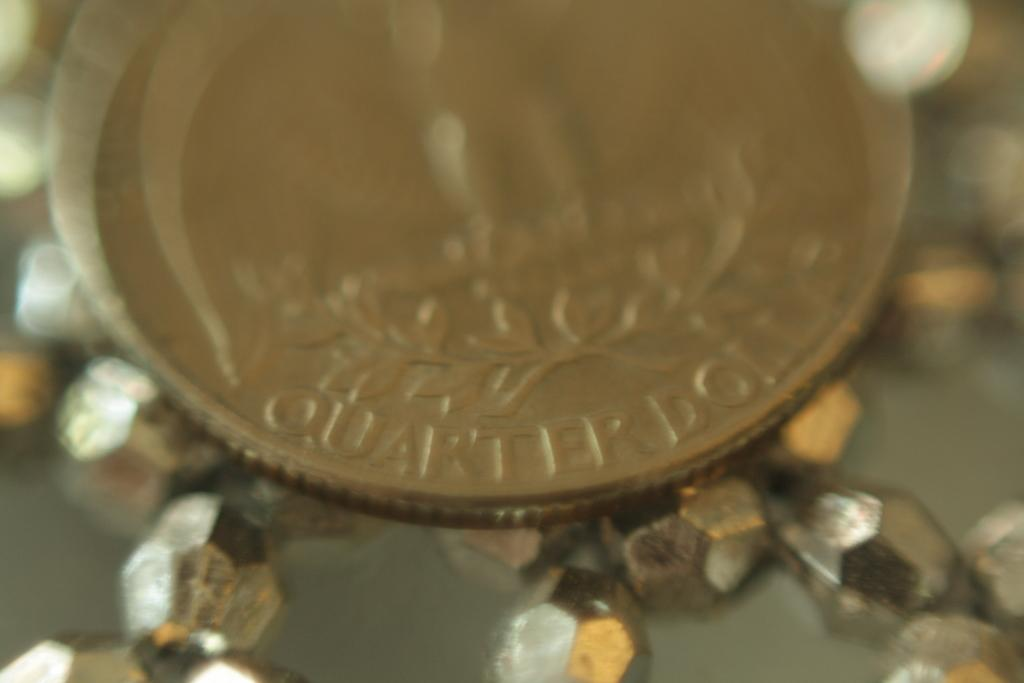What is the main object in the picture? There is a coin in the picture. What type of coin is it? The coin is a "Quarter Dollar". What else can be seen at the bottom of the picture? There are beads at the bottom of the picture. How would you describe the background of the image? The background of the image is blurred. Is it raining in the picture? There is no indication of rain in the picture; it only shows a coin, beads, and a blurred background. 